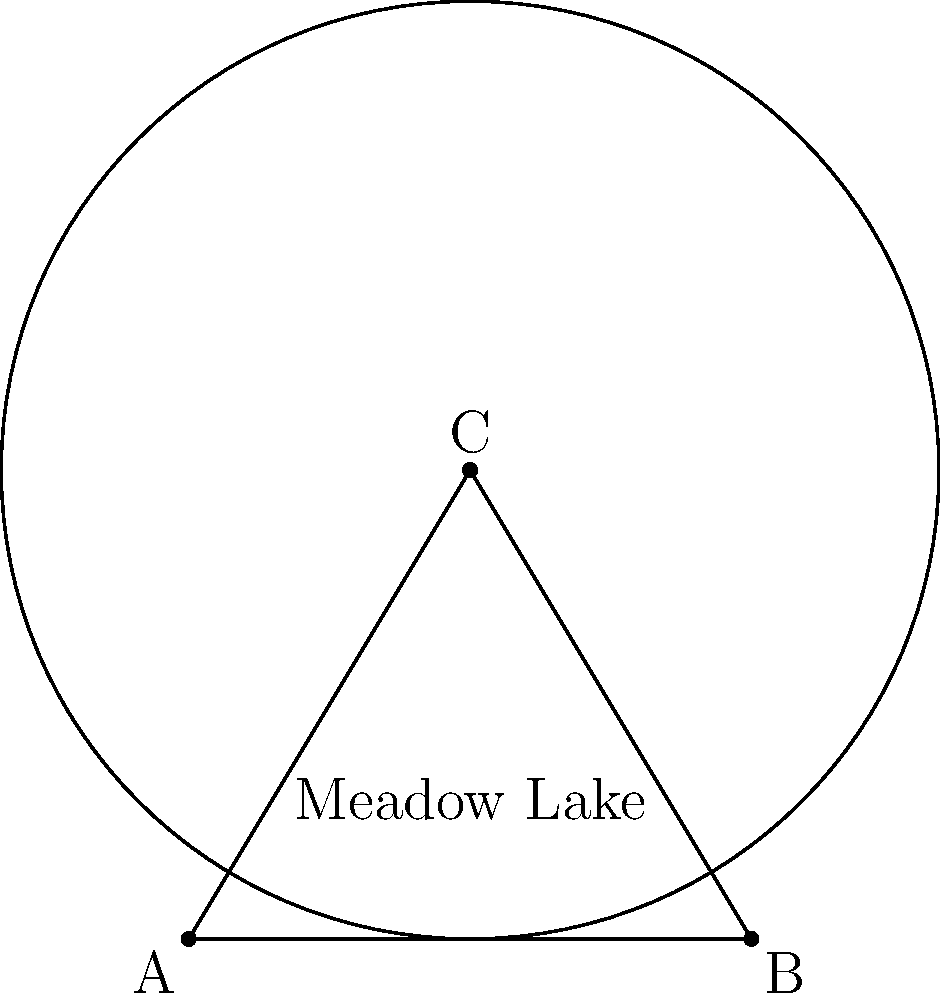The city council of Meadow Lake is planning to install a new cell tower to maximize coverage. The triangular area ABC represents Meadow Lake, where AB = 6 km, and C is 5 km from both A and B. If the cell tower has a range of 5 km, where should it be placed to cover the maximum area of Meadow Lake? To solve this problem, we need to follow these steps:

1) First, we recognize that the triangle ABC is isosceles, with AC = BC = 5 km.

2) The optimal placement for the cell tower would be at a point that can reach all corners of the triangular area.

3) Given that the cell tower has a range of 5 km, which is equal to the length of AC and BC, the ideal location for the tower is at point C.

4) If we place the tower at C, its 5 km range (represented by the circle) will cover the entire triangular area of Meadow Lake.

5) Any other location within the triangle would leave some areas uncovered, as the distance to at least one corner would exceed 5 km.

6) Therefore, point C, which is at the apex of the isosceles triangle, is the optimal location for the cell tower.
Answer: At point C 